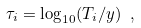<formula> <loc_0><loc_0><loc_500><loc_500>\tau _ { i } = \log _ { 1 0 } ( T _ { i } / y ) \ ,</formula> 